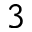<formula> <loc_0><loc_0><loc_500><loc_500>3</formula> 